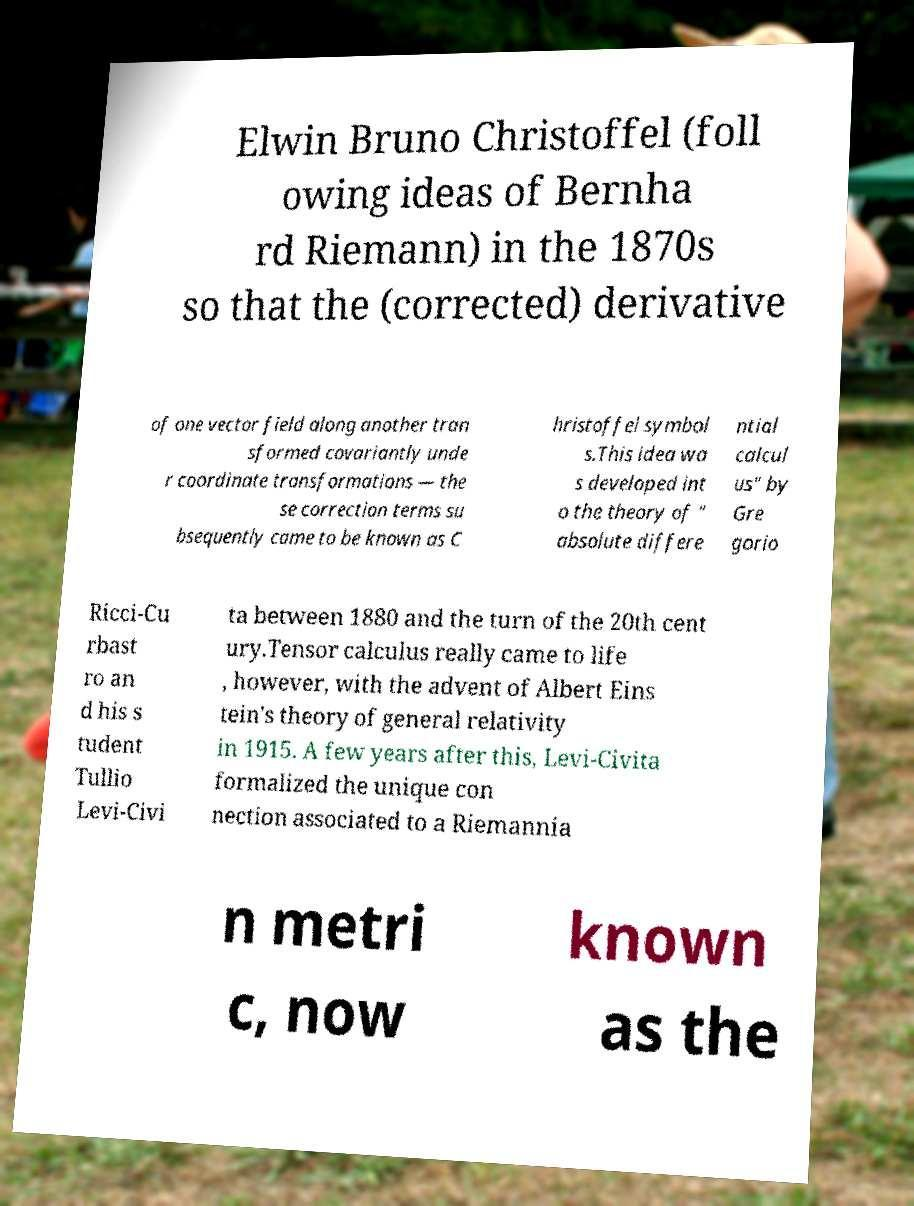For documentation purposes, I need the text within this image transcribed. Could you provide that? Elwin Bruno Christoffel (foll owing ideas of Bernha rd Riemann) in the 1870s so that the (corrected) derivative of one vector field along another tran sformed covariantly unde r coordinate transformations — the se correction terms su bsequently came to be known as C hristoffel symbol s.This idea wa s developed int o the theory of " absolute differe ntial calcul us" by Gre gorio Ricci-Cu rbast ro an d his s tudent Tullio Levi-Civi ta between 1880 and the turn of the 20th cent ury.Tensor calculus really came to life , however, with the advent of Albert Eins tein's theory of general relativity in 1915. A few years after this, Levi-Civita formalized the unique con nection associated to a Riemannia n metri c, now known as the 